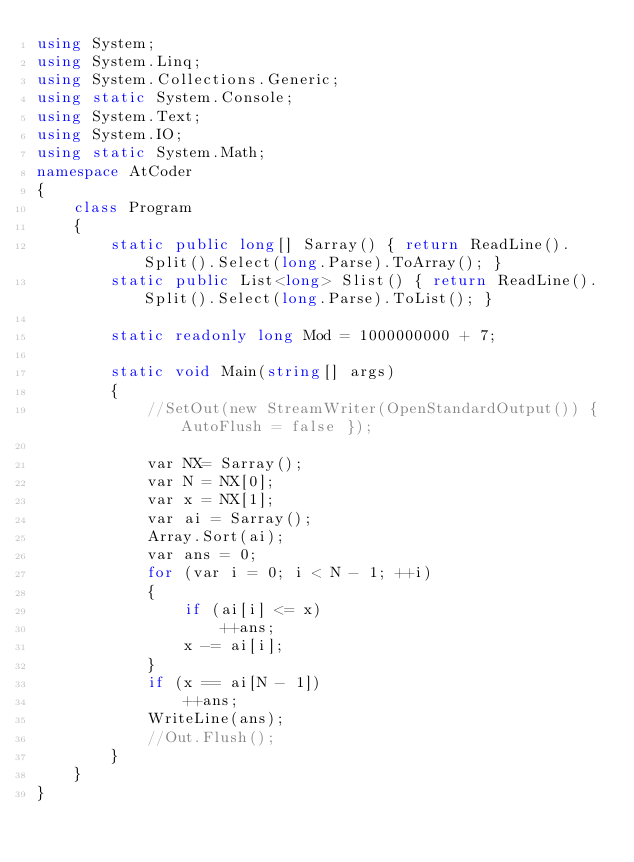Convert code to text. <code><loc_0><loc_0><loc_500><loc_500><_C#_>using System;
using System.Linq;
using System.Collections.Generic;
using static System.Console;
using System.Text;
using System.IO;
using static System.Math;
namespace AtCoder
{
    class Program
    {
        static public long[] Sarray() { return ReadLine().Split().Select(long.Parse).ToArray(); }
        static public List<long> Slist() { return ReadLine().Split().Select(long.Parse).ToList(); }

        static readonly long Mod = 1000000000 + 7;

        static void Main(string[] args)
        {
            //SetOut(new StreamWriter(OpenStandardOutput()) { AutoFlush = false });

            var NX= Sarray();
            var N = NX[0];
            var x = NX[1];
            var ai = Sarray();
            Array.Sort(ai);
            var ans = 0;
            for (var i = 0; i < N - 1; ++i)
            {
                if (ai[i] <= x)
                    ++ans;
                x -= ai[i];
            }
            if (x == ai[N - 1])
                ++ans;
            WriteLine(ans);
            //Out.Flush();
        }
    }
}</code> 